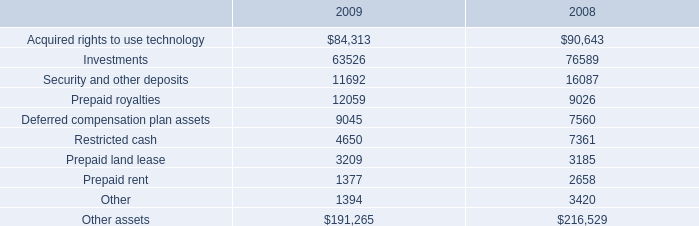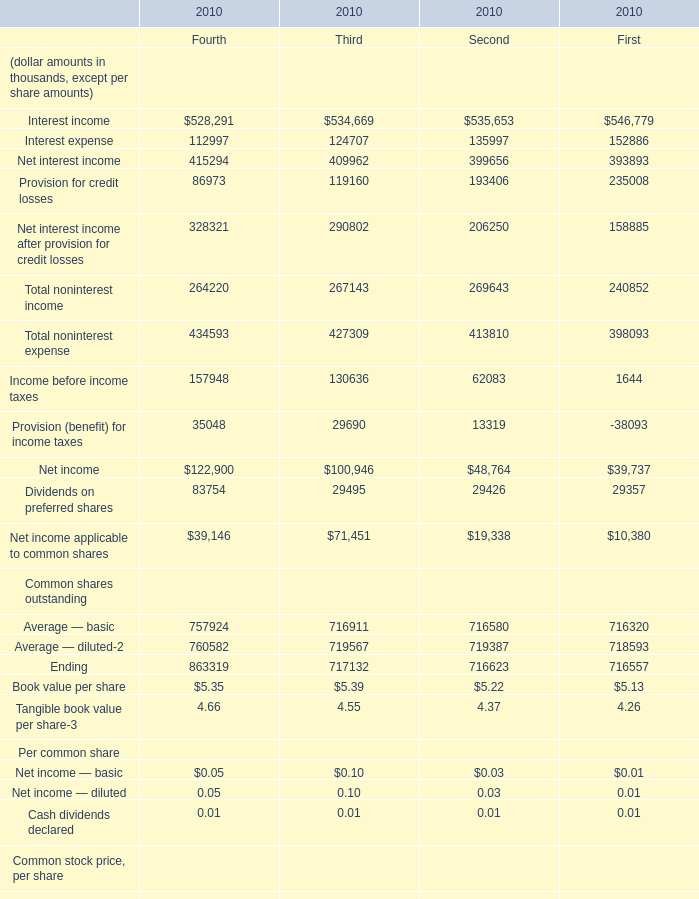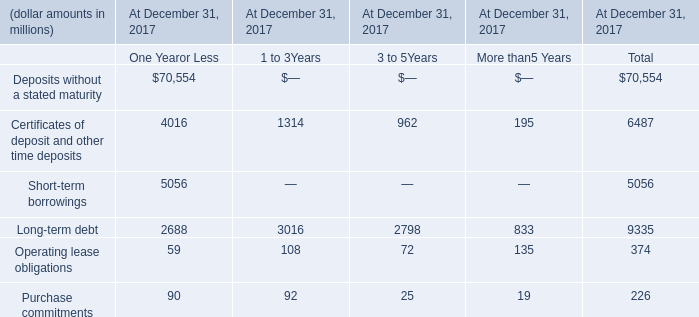What will Provision for credit losses be like in the first quarter of 2011 if it develops with the same growth rate as current quarterly? (in thousand) 
Computations: (86973 * (1 + ((86973 - 119160) / 119160)))
Answer: 63480.2176. 